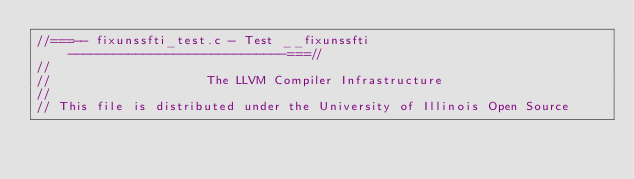Convert code to text. <code><loc_0><loc_0><loc_500><loc_500><_C_>//===-- fixunssfti_test.c - Test __fixunssfti -----------------------------===//
//
//                     The LLVM Compiler Infrastructure
//
// This file is distributed under the University of Illinois Open Source</code> 